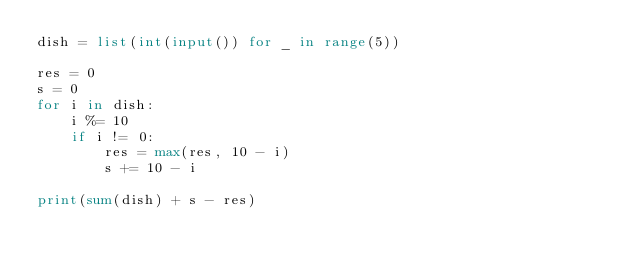Convert code to text. <code><loc_0><loc_0><loc_500><loc_500><_Python_>dish = list(int(input()) for _ in range(5))

res = 0
s = 0
for i in dish:
    i %= 10
    if i != 0:
        res = max(res, 10 - i)
        s += 10 - i

print(sum(dish) + s - res)
</code> 